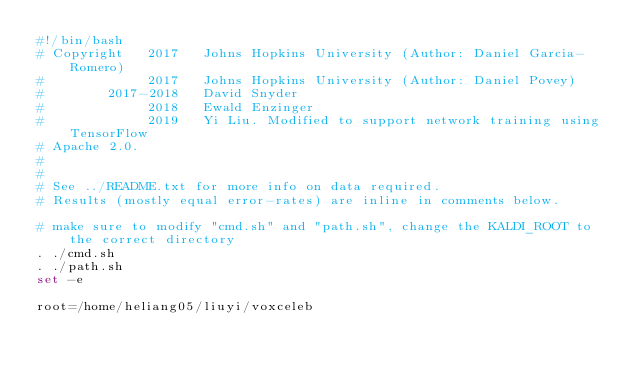Convert code to text. <code><loc_0><loc_0><loc_500><loc_500><_Bash_>#!/bin/bash
# Copyright   2017   Johns Hopkins University (Author: Daniel Garcia-Romero)
#             2017   Johns Hopkins University (Author: Daniel Povey)
#        2017-2018   David Snyder
#             2018   Ewald Enzinger
#             2019   Yi Liu. Modified to support network training using TensorFlow
# Apache 2.0.
#
#
# See ../README.txt for more info on data required.
# Results (mostly equal error-rates) are inline in comments below.

# make sure to modify "cmd.sh" and "path.sh", change the KALDI_ROOT to the correct directory
. ./cmd.sh
. ./path.sh
set -e

root=/home/heliang05/liuyi/voxceleb</code> 